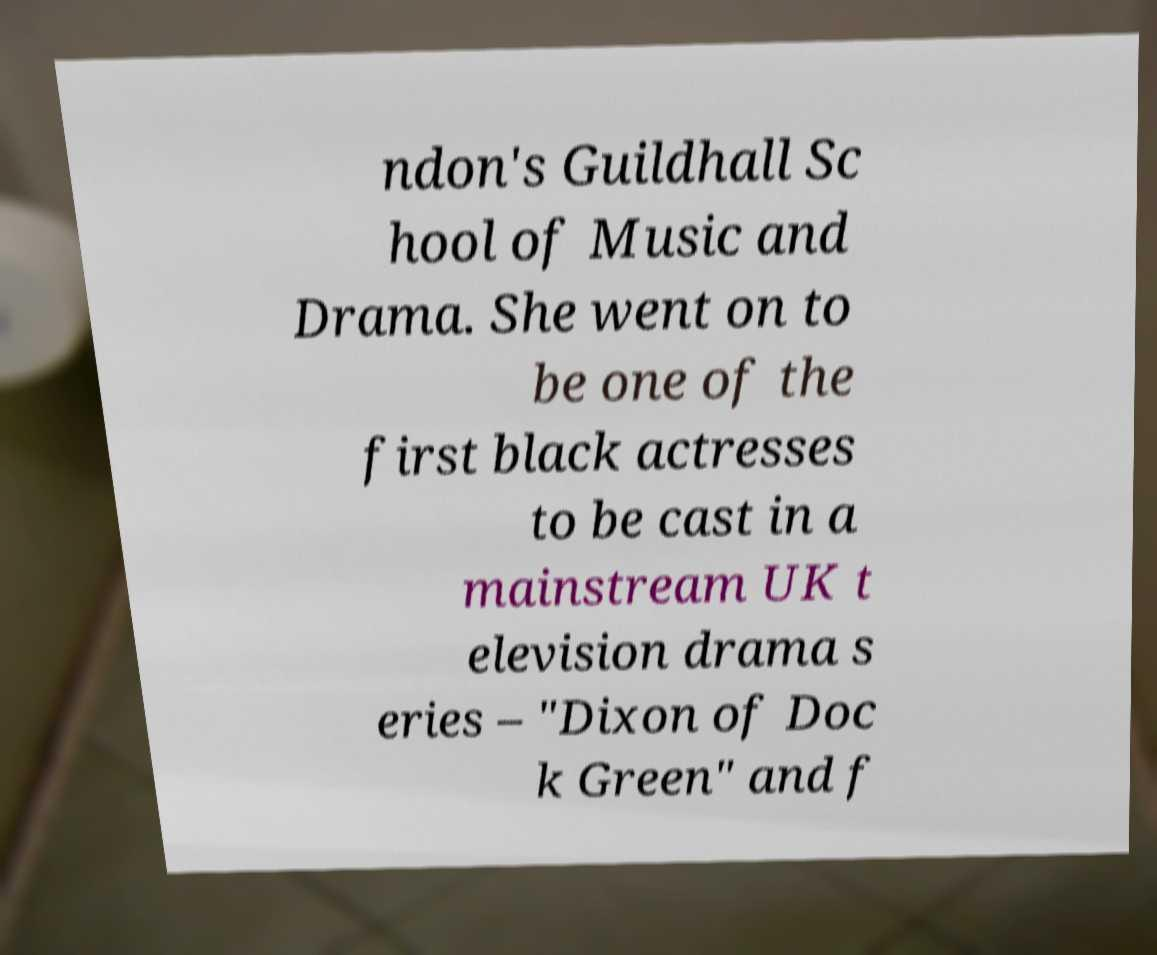Can you accurately transcribe the text from the provided image for me? ndon's Guildhall Sc hool of Music and Drama. She went on to be one of the first black actresses to be cast in a mainstream UK t elevision drama s eries – "Dixon of Doc k Green" and f 